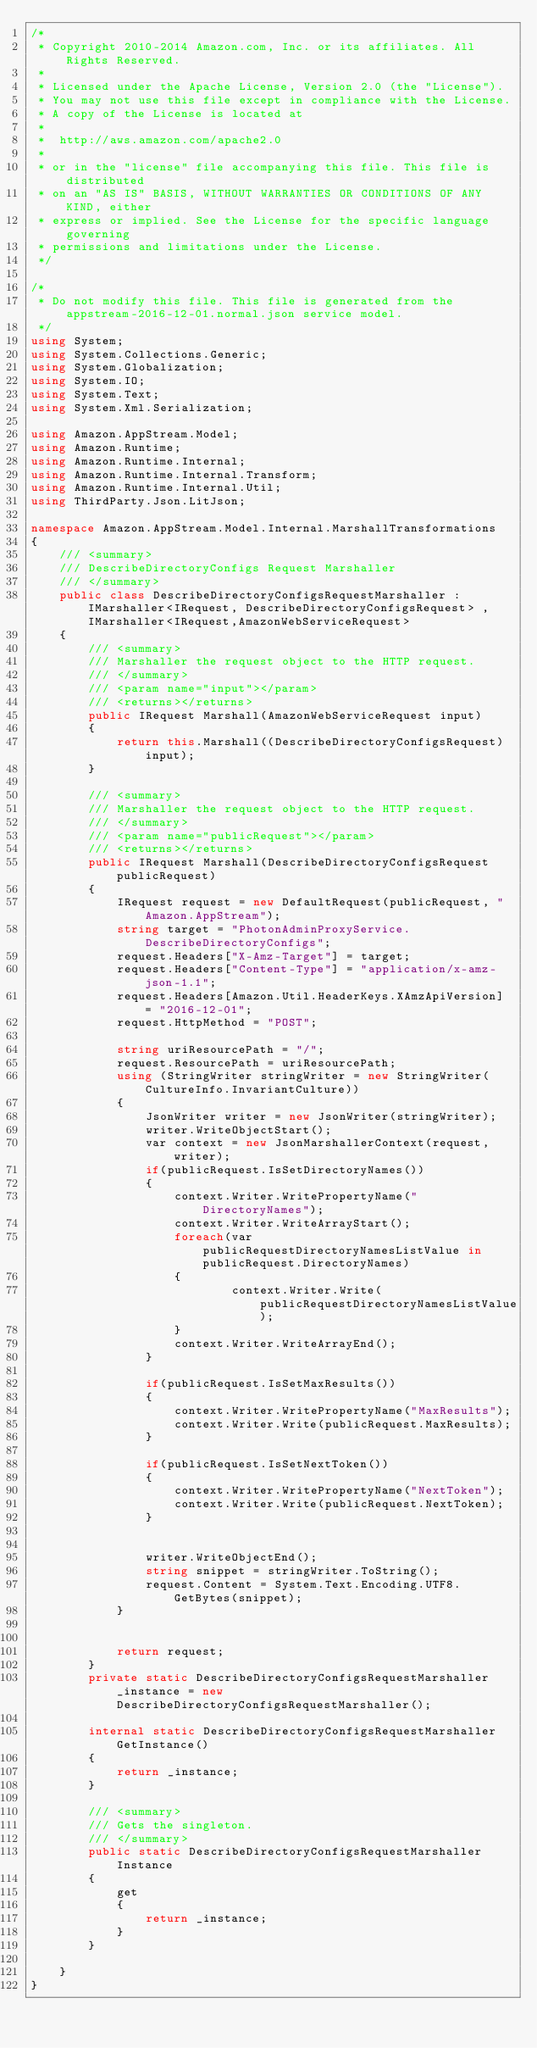Convert code to text. <code><loc_0><loc_0><loc_500><loc_500><_C#_>/*
 * Copyright 2010-2014 Amazon.com, Inc. or its affiliates. All Rights Reserved.
 * 
 * Licensed under the Apache License, Version 2.0 (the "License").
 * You may not use this file except in compliance with the License.
 * A copy of the License is located at
 * 
 *  http://aws.amazon.com/apache2.0
 * 
 * or in the "license" file accompanying this file. This file is distributed
 * on an "AS IS" BASIS, WITHOUT WARRANTIES OR CONDITIONS OF ANY KIND, either
 * express or implied. See the License for the specific language governing
 * permissions and limitations under the License.
 */

/*
 * Do not modify this file. This file is generated from the appstream-2016-12-01.normal.json service model.
 */
using System;
using System.Collections.Generic;
using System.Globalization;
using System.IO;
using System.Text;
using System.Xml.Serialization;

using Amazon.AppStream.Model;
using Amazon.Runtime;
using Amazon.Runtime.Internal;
using Amazon.Runtime.Internal.Transform;
using Amazon.Runtime.Internal.Util;
using ThirdParty.Json.LitJson;

namespace Amazon.AppStream.Model.Internal.MarshallTransformations
{
    /// <summary>
    /// DescribeDirectoryConfigs Request Marshaller
    /// </summary>       
    public class DescribeDirectoryConfigsRequestMarshaller : IMarshaller<IRequest, DescribeDirectoryConfigsRequest> , IMarshaller<IRequest,AmazonWebServiceRequest>
    {
        /// <summary>
        /// Marshaller the request object to the HTTP request.
        /// </summary>  
        /// <param name="input"></param>
        /// <returns></returns>
        public IRequest Marshall(AmazonWebServiceRequest input)
        {
            return this.Marshall((DescribeDirectoryConfigsRequest)input);
        }

        /// <summary>
        /// Marshaller the request object to the HTTP request.
        /// </summary>  
        /// <param name="publicRequest"></param>
        /// <returns></returns>
        public IRequest Marshall(DescribeDirectoryConfigsRequest publicRequest)
        {
            IRequest request = new DefaultRequest(publicRequest, "Amazon.AppStream");
            string target = "PhotonAdminProxyService.DescribeDirectoryConfigs";
            request.Headers["X-Amz-Target"] = target;
            request.Headers["Content-Type"] = "application/x-amz-json-1.1";
            request.Headers[Amazon.Util.HeaderKeys.XAmzApiVersion] = "2016-12-01";            
            request.HttpMethod = "POST";

            string uriResourcePath = "/";
            request.ResourcePath = uriResourcePath;
            using (StringWriter stringWriter = new StringWriter(CultureInfo.InvariantCulture))
            {
                JsonWriter writer = new JsonWriter(stringWriter);
                writer.WriteObjectStart();
                var context = new JsonMarshallerContext(request, writer);
                if(publicRequest.IsSetDirectoryNames())
                {
                    context.Writer.WritePropertyName("DirectoryNames");
                    context.Writer.WriteArrayStart();
                    foreach(var publicRequestDirectoryNamesListValue in publicRequest.DirectoryNames)
                    {
                            context.Writer.Write(publicRequestDirectoryNamesListValue);
                    }
                    context.Writer.WriteArrayEnd();
                }

                if(publicRequest.IsSetMaxResults())
                {
                    context.Writer.WritePropertyName("MaxResults");
                    context.Writer.Write(publicRequest.MaxResults);
                }

                if(publicRequest.IsSetNextToken())
                {
                    context.Writer.WritePropertyName("NextToken");
                    context.Writer.Write(publicRequest.NextToken);
                }

        
                writer.WriteObjectEnd();
                string snippet = stringWriter.ToString();
                request.Content = System.Text.Encoding.UTF8.GetBytes(snippet);
            }


            return request;
        }
        private static DescribeDirectoryConfigsRequestMarshaller _instance = new DescribeDirectoryConfigsRequestMarshaller();        

        internal static DescribeDirectoryConfigsRequestMarshaller GetInstance()
        {
            return _instance;
        }

        /// <summary>
        /// Gets the singleton.
        /// </summary>  
        public static DescribeDirectoryConfigsRequestMarshaller Instance
        {
            get
            {
                return _instance;
            }
        }

    }
}</code> 